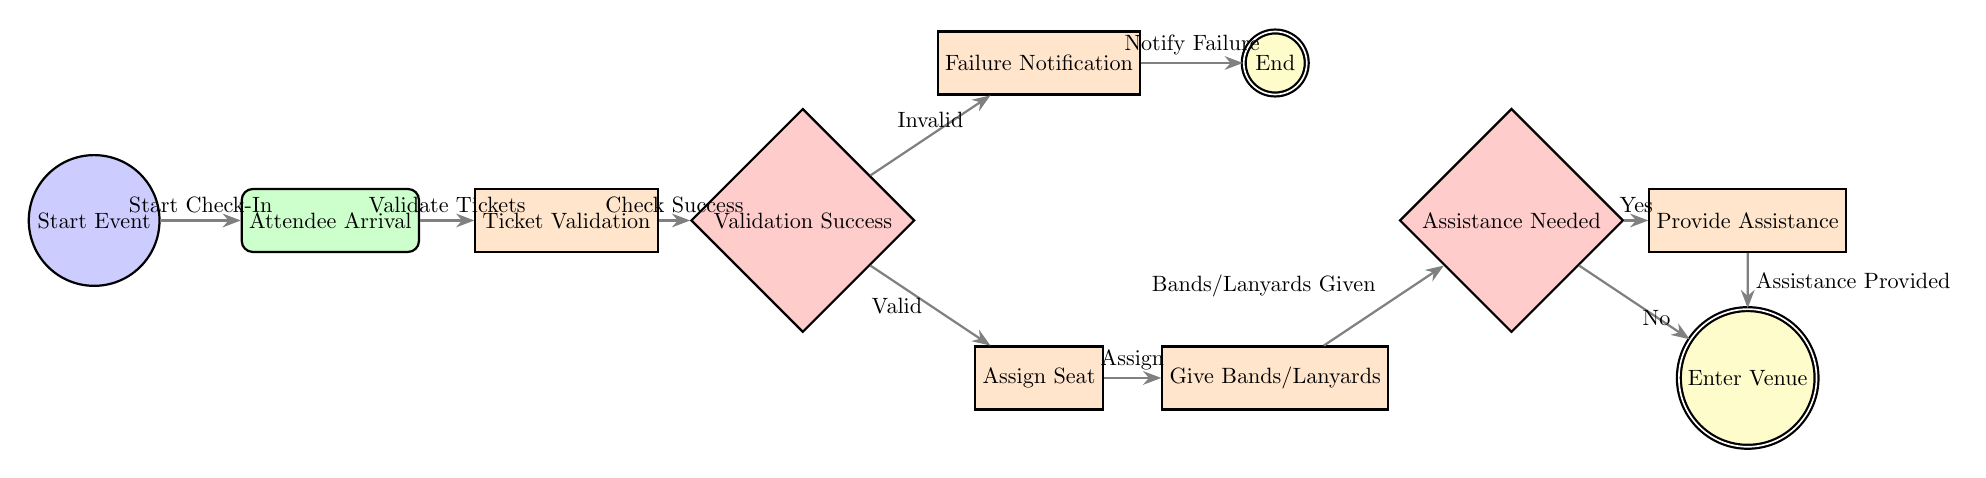What is the first node in the diagram? The first node is indicated by the initial node style and labeled "Start Event".
Answer: Start Event How many main processes are there in total? By counting the nodes categorized as processes, there are four main processes: Ticket Validation, Assign Seat, Give Bands/Lanyards, and Provide Assistance.
Answer: 4 What is the outcome if the ticket validation is successful? The outcome is determined by a valid ticket which leads to the Assign Seat process. This implies that a successful validation leads to the next key action of assigning a seat.
Answer: Assign Seat What happens if the ticket validation fails? If the ticket validation fails, the process leads to the Failure Notification step, which is designated for notifying an issue with the ticket validation.
Answer: Failure Notification Which decision node follows the Give Bands/Lanyards process? After the Give Bands/Lanyards process, the next node is the Assistance Needed decision node, which determines if assistance is required for the attendee.
Answer: Assistance Needed What is the final outcome for attendees after they successfully check in? The final outcome after successfully checking in and completing all necessary processes is that attendees will Enter Venue.
Answer: Enter Venue What happens if assistance is needed during check-in? If assistance is needed, the flow directs to the Provide Assistance process, indicating that help is provided before attendees can continue.
Answer: Provide Assistance How many nodes are related to decisions in this diagram? There are two decision nodes: Validation Success and Assistance Needed. These nodes dictate the flow based on specific conditions.
Answer: 2 What action is taken if no assistance is required? If no assistance is required, the flow proceeds directly to the Enter Venue process, allowing attendees to enter without additional help.
Answer: Enter Venue 